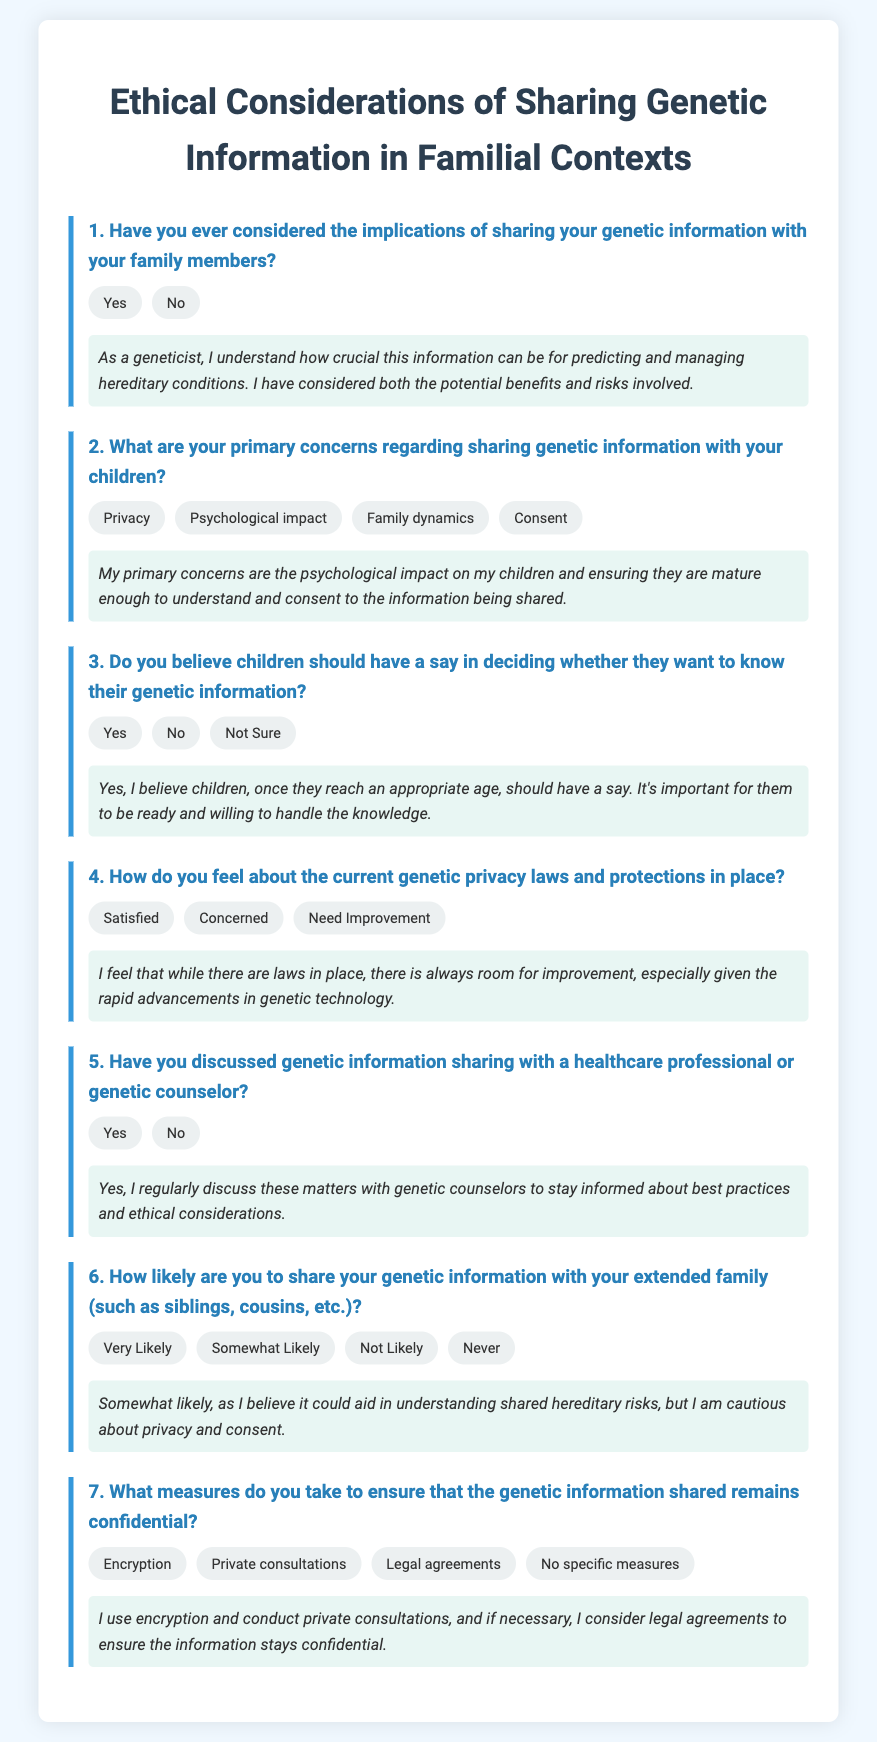What is the main topic of the questionnaire? The main topic of the questionnaire is the ethical considerations of sharing genetic information in familial contexts.
Answer: Ethical considerations of sharing genetic information in familial contexts How many primary concerns are listed regarding sharing genetic information with children? There are four primary concerns listed about sharing genetic information with children.
Answer: Four What is the response indicating concern about current genetic privacy laws? The response reflecting concern about current genetic privacy laws is "Concerned".
Answer: Concerned What is the level of likelihood to share genetic information with extended family? The response indicating likelihood is "Somewhat Likely".
Answer: Somewhat Likely What specific measures are mentioned to ensure confidentiality of shared genetic information? The specific measures mentioned include encryption, private consultations, and legal agreements.
Answer: Encryption, private consultations, legal agreements Do the parents believe children should have a say in knowing their genetic information? Yes, they believe children should have a say.
Answer: Yes How do the respondents feel about the current genetic privacy laws? The respondents feel that the current genetic privacy laws "Need Improvement".
Answer: Need Improvement What percentage of respondents have discussed genetic information sharing with a healthcare professional? The document states that the respondents who have discussed this are indicated by "Yes".
Answer: Yes 